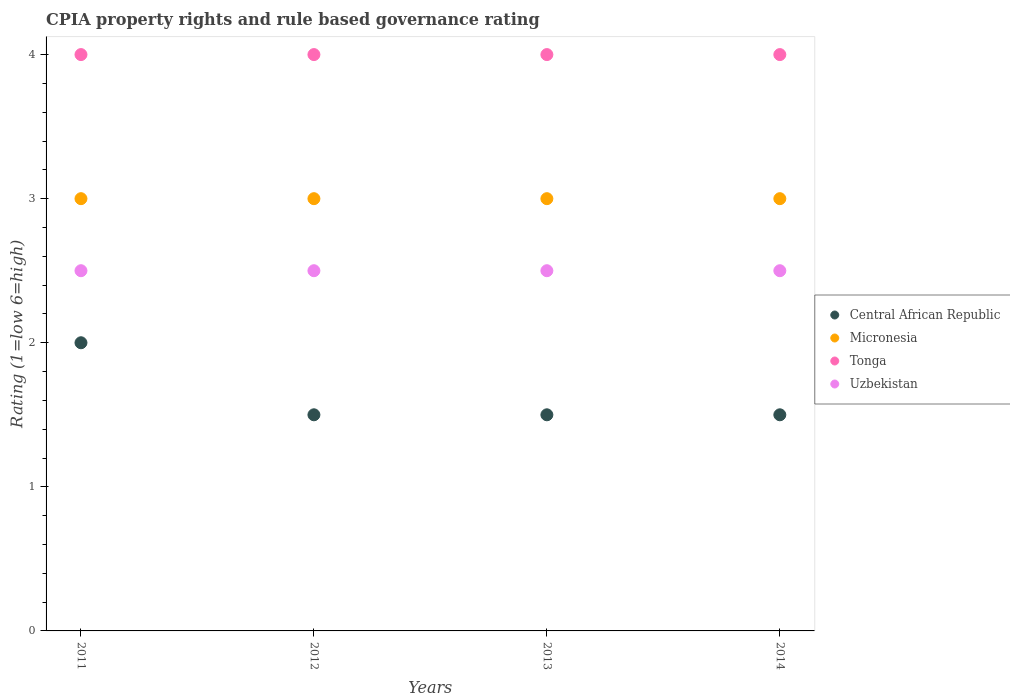Is the number of dotlines equal to the number of legend labels?
Give a very brief answer. Yes. What is the CPIA rating in Micronesia in 2011?
Make the answer very short. 3. Across all years, what is the minimum CPIA rating in Uzbekistan?
Provide a short and direct response. 2.5. In which year was the CPIA rating in Central African Republic maximum?
Make the answer very short. 2011. In which year was the CPIA rating in Micronesia minimum?
Ensure brevity in your answer.  2011. What is the difference between the CPIA rating in Central African Republic in 2012 and that in 2013?
Offer a very short reply. 0. What is the average CPIA rating in Uzbekistan per year?
Offer a terse response. 2.5. In the year 2011, what is the difference between the CPIA rating in Micronesia and CPIA rating in Uzbekistan?
Provide a succinct answer. 0.5. What is the difference between the highest and the second highest CPIA rating in Micronesia?
Provide a short and direct response. 0. What is the difference between the highest and the lowest CPIA rating in Micronesia?
Offer a very short reply. 0. In how many years, is the CPIA rating in Uzbekistan greater than the average CPIA rating in Uzbekistan taken over all years?
Keep it short and to the point. 0. How many dotlines are there?
Keep it short and to the point. 4. How many years are there in the graph?
Ensure brevity in your answer.  4. Where does the legend appear in the graph?
Provide a short and direct response. Center right. How are the legend labels stacked?
Your answer should be compact. Vertical. What is the title of the graph?
Provide a short and direct response. CPIA property rights and rule based governance rating. Does "Comoros" appear as one of the legend labels in the graph?
Your response must be concise. No. What is the Rating (1=low 6=high) of Central African Republic in 2011?
Make the answer very short. 2. What is the Rating (1=low 6=high) of Micronesia in 2011?
Keep it short and to the point. 3. What is the Rating (1=low 6=high) in Tonga in 2011?
Provide a short and direct response. 4. What is the Rating (1=low 6=high) in Uzbekistan in 2011?
Provide a succinct answer. 2.5. What is the Rating (1=low 6=high) of Central African Republic in 2012?
Ensure brevity in your answer.  1.5. What is the Rating (1=low 6=high) of Micronesia in 2012?
Give a very brief answer. 3. What is the Rating (1=low 6=high) of Central African Republic in 2013?
Your response must be concise. 1.5. What is the Rating (1=low 6=high) of Uzbekistan in 2013?
Your answer should be compact. 2.5. What is the Rating (1=low 6=high) of Micronesia in 2014?
Offer a very short reply. 3. What is the Rating (1=low 6=high) of Uzbekistan in 2014?
Your answer should be very brief. 2.5. Across all years, what is the maximum Rating (1=low 6=high) of Central African Republic?
Your answer should be very brief. 2. Across all years, what is the maximum Rating (1=low 6=high) in Micronesia?
Your answer should be very brief. 3. Across all years, what is the maximum Rating (1=low 6=high) of Tonga?
Offer a very short reply. 4. Across all years, what is the maximum Rating (1=low 6=high) of Uzbekistan?
Provide a succinct answer. 2.5. Across all years, what is the minimum Rating (1=low 6=high) in Micronesia?
Ensure brevity in your answer.  3. Across all years, what is the minimum Rating (1=low 6=high) in Tonga?
Make the answer very short. 4. Across all years, what is the minimum Rating (1=low 6=high) of Uzbekistan?
Provide a short and direct response. 2.5. What is the total Rating (1=low 6=high) of Tonga in the graph?
Give a very brief answer. 16. What is the total Rating (1=low 6=high) of Uzbekistan in the graph?
Your answer should be very brief. 10. What is the difference between the Rating (1=low 6=high) of Micronesia in 2011 and that in 2012?
Give a very brief answer. 0. What is the difference between the Rating (1=low 6=high) in Tonga in 2011 and that in 2012?
Your answer should be compact. 0. What is the difference between the Rating (1=low 6=high) of Uzbekistan in 2011 and that in 2012?
Your response must be concise. 0. What is the difference between the Rating (1=low 6=high) in Central African Republic in 2011 and that in 2013?
Make the answer very short. 0.5. What is the difference between the Rating (1=low 6=high) in Uzbekistan in 2011 and that in 2013?
Your answer should be compact. 0. What is the difference between the Rating (1=low 6=high) in Central African Republic in 2011 and that in 2014?
Offer a terse response. 0.5. What is the difference between the Rating (1=low 6=high) of Tonga in 2011 and that in 2014?
Provide a short and direct response. 0. What is the difference between the Rating (1=low 6=high) in Micronesia in 2012 and that in 2013?
Your response must be concise. 0. What is the difference between the Rating (1=low 6=high) of Uzbekistan in 2012 and that in 2013?
Offer a very short reply. 0. What is the difference between the Rating (1=low 6=high) in Micronesia in 2012 and that in 2014?
Your answer should be compact. 0. What is the difference between the Rating (1=low 6=high) of Uzbekistan in 2012 and that in 2014?
Ensure brevity in your answer.  0. What is the difference between the Rating (1=low 6=high) in Central African Republic in 2013 and that in 2014?
Offer a very short reply. 0. What is the difference between the Rating (1=low 6=high) in Uzbekistan in 2013 and that in 2014?
Provide a succinct answer. 0. What is the difference between the Rating (1=low 6=high) in Central African Republic in 2011 and the Rating (1=low 6=high) in Tonga in 2012?
Your response must be concise. -2. What is the difference between the Rating (1=low 6=high) of Central African Republic in 2011 and the Rating (1=low 6=high) of Uzbekistan in 2012?
Make the answer very short. -0.5. What is the difference between the Rating (1=low 6=high) of Micronesia in 2011 and the Rating (1=low 6=high) of Tonga in 2012?
Give a very brief answer. -1. What is the difference between the Rating (1=low 6=high) in Tonga in 2011 and the Rating (1=low 6=high) in Uzbekistan in 2012?
Ensure brevity in your answer.  1.5. What is the difference between the Rating (1=low 6=high) of Tonga in 2011 and the Rating (1=low 6=high) of Uzbekistan in 2013?
Your answer should be very brief. 1.5. What is the difference between the Rating (1=low 6=high) of Central African Republic in 2011 and the Rating (1=low 6=high) of Micronesia in 2014?
Provide a succinct answer. -1. What is the difference between the Rating (1=low 6=high) of Micronesia in 2011 and the Rating (1=low 6=high) of Tonga in 2014?
Ensure brevity in your answer.  -1. What is the difference between the Rating (1=low 6=high) of Central African Republic in 2012 and the Rating (1=low 6=high) of Micronesia in 2013?
Your response must be concise. -1.5. What is the difference between the Rating (1=low 6=high) of Central African Republic in 2012 and the Rating (1=low 6=high) of Tonga in 2013?
Offer a terse response. -2.5. What is the difference between the Rating (1=low 6=high) of Central African Republic in 2012 and the Rating (1=low 6=high) of Uzbekistan in 2013?
Offer a very short reply. -1. What is the difference between the Rating (1=low 6=high) in Micronesia in 2012 and the Rating (1=low 6=high) in Tonga in 2013?
Keep it short and to the point. -1. What is the difference between the Rating (1=low 6=high) in Micronesia in 2012 and the Rating (1=low 6=high) in Uzbekistan in 2013?
Give a very brief answer. 0.5. What is the difference between the Rating (1=low 6=high) in Central African Republic in 2012 and the Rating (1=low 6=high) in Tonga in 2014?
Your answer should be very brief. -2.5. What is the difference between the Rating (1=low 6=high) in Central African Republic in 2012 and the Rating (1=low 6=high) in Uzbekistan in 2014?
Make the answer very short. -1. What is the difference between the Rating (1=low 6=high) of Micronesia in 2012 and the Rating (1=low 6=high) of Uzbekistan in 2014?
Keep it short and to the point. 0.5. What is the difference between the Rating (1=low 6=high) in Tonga in 2012 and the Rating (1=low 6=high) in Uzbekistan in 2014?
Keep it short and to the point. 1.5. What is the difference between the Rating (1=low 6=high) of Central African Republic in 2013 and the Rating (1=low 6=high) of Micronesia in 2014?
Provide a short and direct response. -1.5. What is the difference between the Rating (1=low 6=high) in Central African Republic in 2013 and the Rating (1=low 6=high) in Uzbekistan in 2014?
Provide a short and direct response. -1. What is the difference between the Rating (1=low 6=high) of Micronesia in 2013 and the Rating (1=low 6=high) of Uzbekistan in 2014?
Offer a very short reply. 0.5. What is the average Rating (1=low 6=high) of Central African Republic per year?
Ensure brevity in your answer.  1.62. What is the average Rating (1=low 6=high) of Micronesia per year?
Keep it short and to the point. 3. What is the average Rating (1=low 6=high) of Uzbekistan per year?
Ensure brevity in your answer.  2.5. In the year 2012, what is the difference between the Rating (1=low 6=high) of Central African Republic and Rating (1=low 6=high) of Tonga?
Give a very brief answer. -2.5. In the year 2012, what is the difference between the Rating (1=low 6=high) of Micronesia and Rating (1=low 6=high) of Uzbekistan?
Provide a short and direct response. 0.5. In the year 2012, what is the difference between the Rating (1=low 6=high) of Tonga and Rating (1=low 6=high) of Uzbekistan?
Make the answer very short. 1.5. In the year 2013, what is the difference between the Rating (1=low 6=high) of Central African Republic and Rating (1=low 6=high) of Micronesia?
Give a very brief answer. -1.5. In the year 2013, what is the difference between the Rating (1=low 6=high) of Central African Republic and Rating (1=low 6=high) of Uzbekistan?
Keep it short and to the point. -1. In the year 2013, what is the difference between the Rating (1=low 6=high) of Micronesia and Rating (1=low 6=high) of Tonga?
Your response must be concise. -1. In the year 2013, what is the difference between the Rating (1=low 6=high) in Tonga and Rating (1=low 6=high) in Uzbekistan?
Your answer should be very brief. 1.5. In the year 2014, what is the difference between the Rating (1=low 6=high) of Central African Republic and Rating (1=low 6=high) of Micronesia?
Your answer should be compact. -1.5. In the year 2014, what is the difference between the Rating (1=low 6=high) of Central African Republic and Rating (1=low 6=high) of Tonga?
Offer a terse response. -2.5. In the year 2014, what is the difference between the Rating (1=low 6=high) of Central African Republic and Rating (1=low 6=high) of Uzbekistan?
Make the answer very short. -1. In the year 2014, what is the difference between the Rating (1=low 6=high) in Micronesia and Rating (1=low 6=high) in Uzbekistan?
Ensure brevity in your answer.  0.5. In the year 2014, what is the difference between the Rating (1=low 6=high) in Tonga and Rating (1=low 6=high) in Uzbekistan?
Offer a very short reply. 1.5. What is the ratio of the Rating (1=low 6=high) in Central African Republic in 2011 to that in 2012?
Provide a succinct answer. 1.33. What is the ratio of the Rating (1=low 6=high) in Central African Republic in 2011 to that in 2013?
Your answer should be very brief. 1.33. What is the ratio of the Rating (1=low 6=high) in Uzbekistan in 2011 to that in 2013?
Your response must be concise. 1. What is the ratio of the Rating (1=low 6=high) of Tonga in 2011 to that in 2014?
Ensure brevity in your answer.  1. What is the ratio of the Rating (1=low 6=high) of Central African Republic in 2012 to that in 2013?
Your response must be concise. 1. What is the ratio of the Rating (1=low 6=high) in Uzbekistan in 2012 to that in 2013?
Your answer should be very brief. 1. What is the ratio of the Rating (1=low 6=high) of Micronesia in 2013 to that in 2014?
Offer a very short reply. 1. What is the ratio of the Rating (1=low 6=high) of Tonga in 2013 to that in 2014?
Your response must be concise. 1. What is the ratio of the Rating (1=low 6=high) in Uzbekistan in 2013 to that in 2014?
Your answer should be compact. 1. What is the difference between the highest and the second highest Rating (1=low 6=high) of Central African Republic?
Offer a very short reply. 0.5. What is the difference between the highest and the second highest Rating (1=low 6=high) in Tonga?
Give a very brief answer. 0. What is the difference between the highest and the second highest Rating (1=low 6=high) in Uzbekistan?
Keep it short and to the point. 0. What is the difference between the highest and the lowest Rating (1=low 6=high) in Micronesia?
Offer a terse response. 0. What is the difference between the highest and the lowest Rating (1=low 6=high) of Tonga?
Make the answer very short. 0. What is the difference between the highest and the lowest Rating (1=low 6=high) of Uzbekistan?
Make the answer very short. 0. 